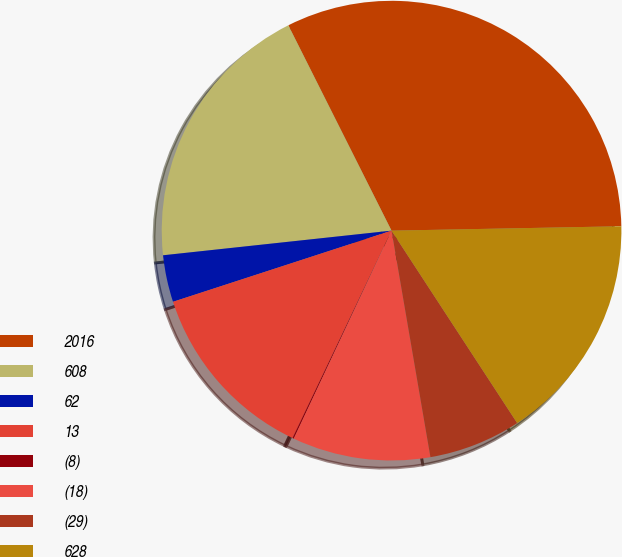Convert chart. <chart><loc_0><loc_0><loc_500><loc_500><pie_chart><fcel>2016<fcel>608<fcel>62<fcel>13<fcel>(8)<fcel>(18)<fcel>(29)<fcel>628<nl><fcel>32.11%<fcel>19.3%<fcel>3.3%<fcel>12.9%<fcel>0.1%<fcel>9.7%<fcel>6.5%<fcel>16.1%<nl></chart> 